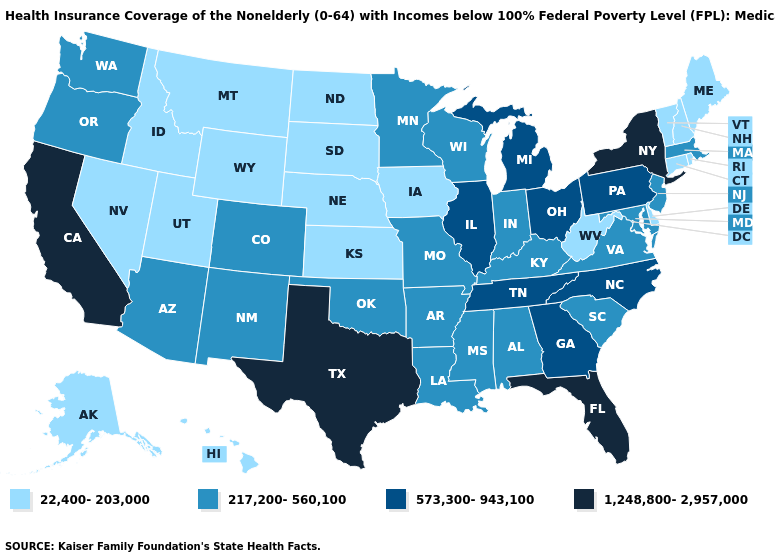How many symbols are there in the legend?
Be succinct. 4. Name the states that have a value in the range 1,248,800-2,957,000?
Keep it brief. California, Florida, New York, Texas. Does Florida have the highest value in the USA?
Be succinct. Yes. What is the value of New Jersey?
Answer briefly. 217,200-560,100. Does New Jersey have the lowest value in the Northeast?
Answer briefly. No. Name the states that have a value in the range 217,200-560,100?
Answer briefly. Alabama, Arizona, Arkansas, Colorado, Indiana, Kentucky, Louisiana, Maryland, Massachusetts, Minnesota, Mississippi, Missouri, New Jersey, New Mexico, Oklahoma, Oregon, South Carolina, Virginia, Washington, Wisconsin. Among the states that border Pennsylvania , does Delaware have the highest value?
Write a very short answer. No. What is the lowest value in states that border Oklahoma?
Give a very brief answer. 22,400-203,000. Name the states that have a value in the range 573,300-943,100?
Give a very brief answer. Georgia, Illinois, Michigan, North Carolina, Ohio, Pennsylvania, Tennessee. What is the value of Alabama?
Quick response, please. 217,200-560,100. Which states have the lowest value in the USA?
Answer briefly. Alaska, Connecticut, Delaware, Hawaii, Idaho, Iowa, Kansas, Maine, Montana, Nebraska, Nevada, New Hampshire, North Dakota, Rhode Island, South Dakota, Utah, Vermont, West Virginia, Wyoming. Does Maine have the lowest value in the USA?
Quick response, please. Yes. Name the states that have a value in the range 22,400-203,000?
Quick response, please. Alaska, Connecticut, Delaware, Hawaii, Idaho, Iowa, Kansas, Maine, Montana, Nebraska, Nevada, New Hampshire, North Dakota, Rhode Island, South Dakota, Utah, Vermont, West Virginia, Wyoming. What is the value of Iowa?
Quick response, please. 22,400-203,000. Is the legend a continuous bar?
Quick response, please. No. 